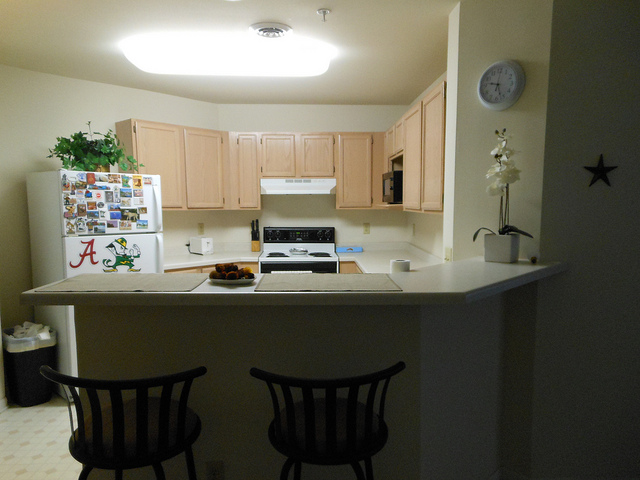Identify and read out the text in this image. A 